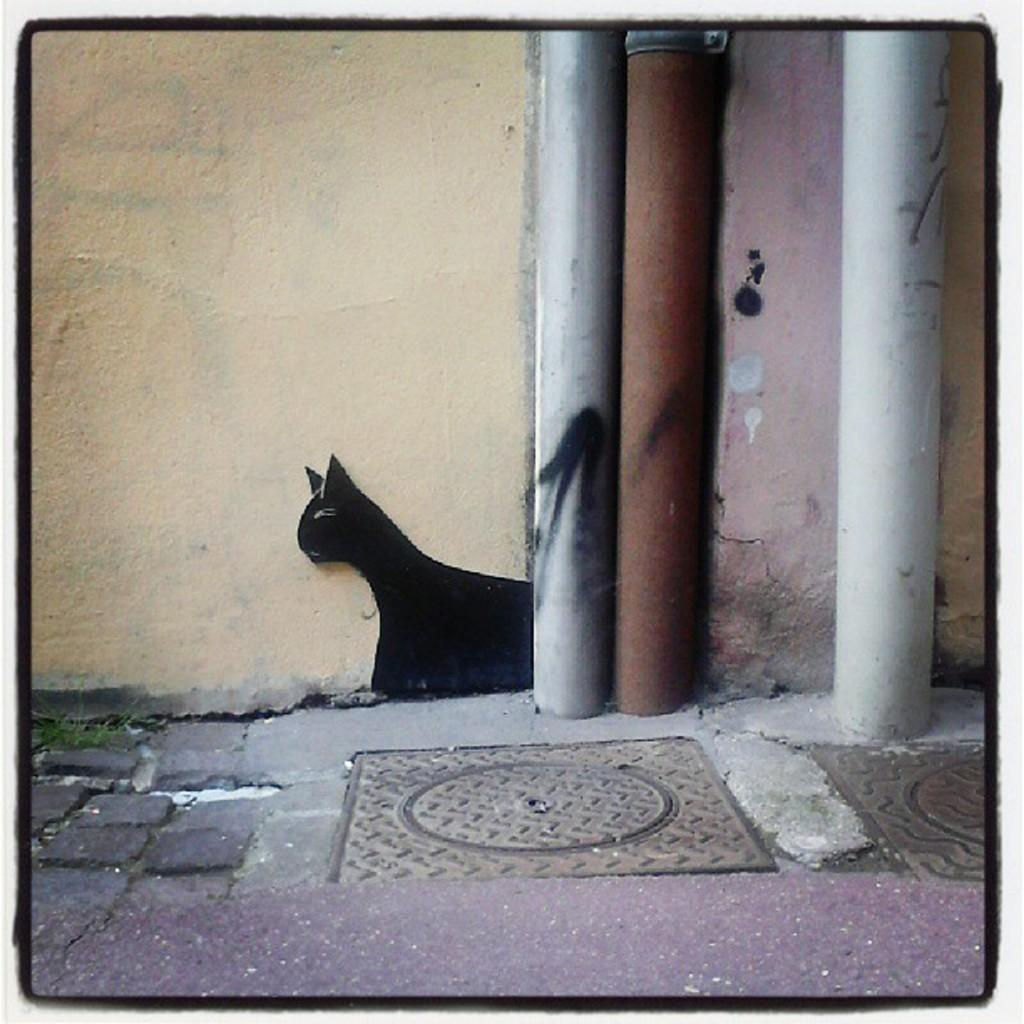What can be seen in the foreground of the image? There are pipes in the foreground of the image. What is located on the ground in the image? There is a manhole on the ground in the image. Can you describe something on a wall in the image? There is a cat sketch on a wall in the image. What type of wren can be seen perched on the pipes in the image? There is no wren present in the image; it features pipes, a manhole, and a cat sketch on a wall. How many kittens are playing with the cat sketch in the image? There are no kittens present in the image; it only features a cat sketch on a wall. 